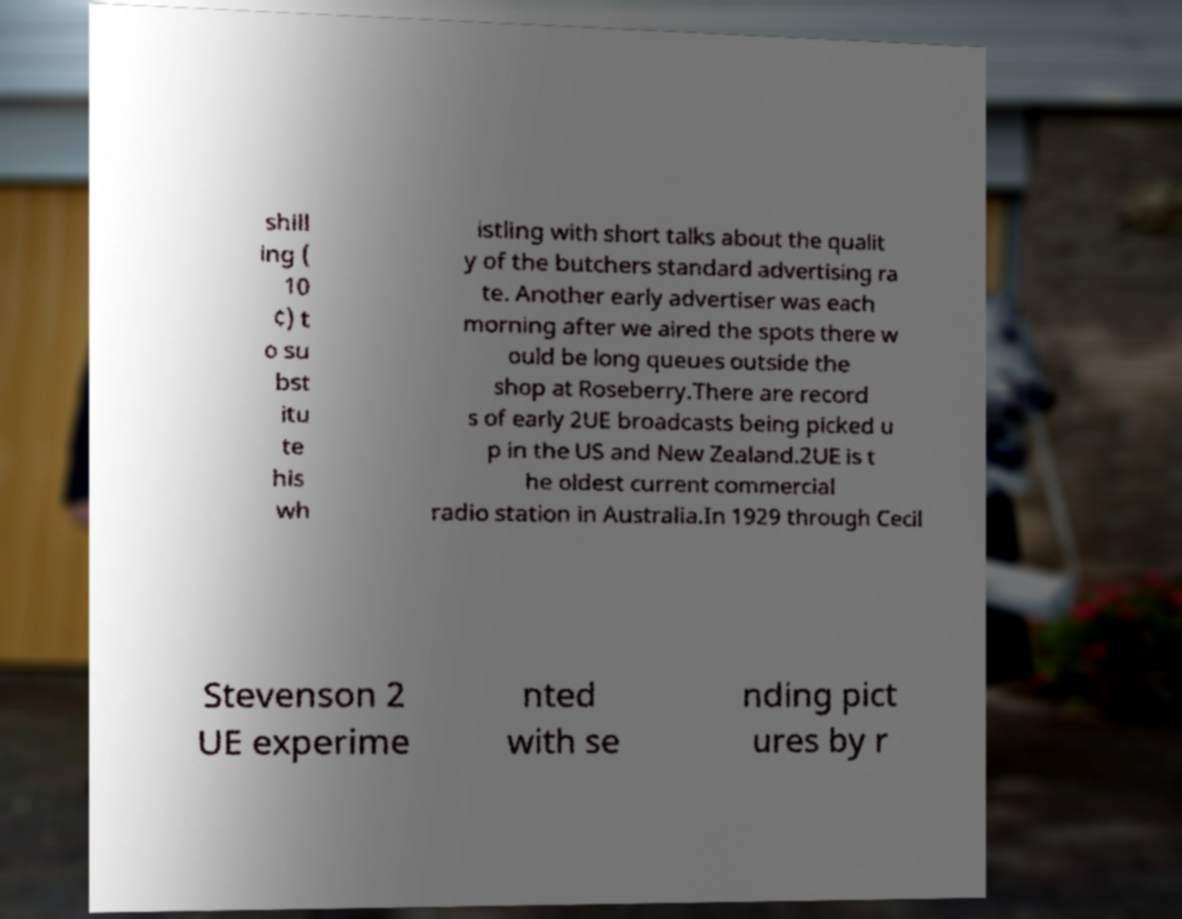There's text embedded in this image that I need extracted. Can you transcribe it verbatim? shill ing ( 10 ¢) t o su bst itu te his wh istling with short talks about the qualit y of the butchers standard advertising ra te. Another early advertiser was each morning after we aired the spots there w ould be long queues outside the shop at Roseberry.There are record s of early 2UE broadcasts being picked u p in the US and New Zealand.2UE is t he oldest current commercial radio station in Australia.In 1929 through Cecil Stevenson 2 UE experime nted with se nding pict ures by r 